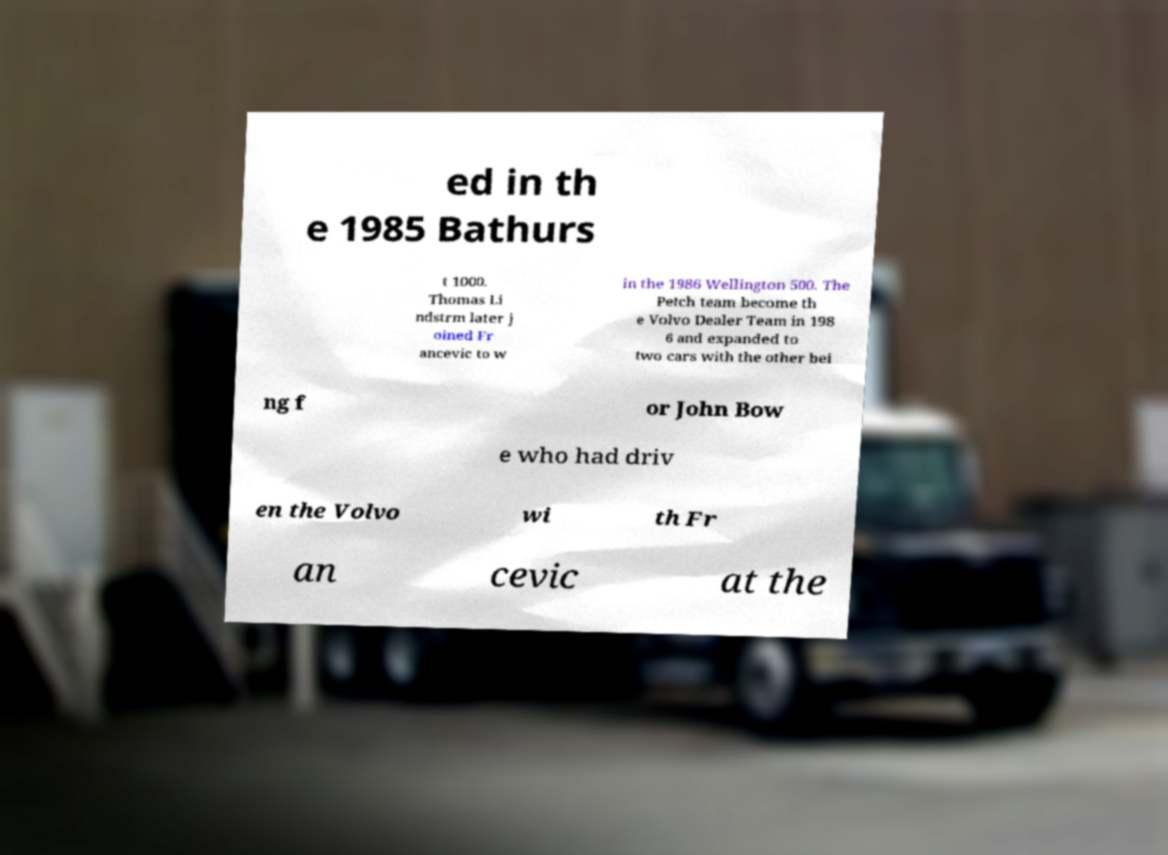For documentation purposes, I need the text within this image transcribed. Could you provide that? ed in th e 1985 Bathurs t 1000. Thomas Li ndstrm later j oined Fr ancevic to w in the 1986 Wellington 500. The Petch team become th e Volvo Dealer Team in 198 6 and expanded to two cars with the other bei ng f or John Bow e who had driv en the Volvo wi th Fr an cevic at the 